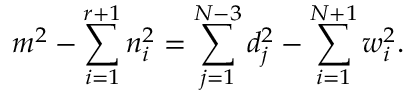<formula> <loc_0><loc_0><loc_500><loc_500>m ^ { 2 } - \sum _ { i = 1 } ^ { r + 1 } n _ { i } ^ { 2 } = \sum _ { j = 1 } ^ { N - 3 } d _ { j } ^ { 2 } - \sum _ { i = 1 } ^ { N + 1 } w _ { i } ^ { 2 } .</formula> 